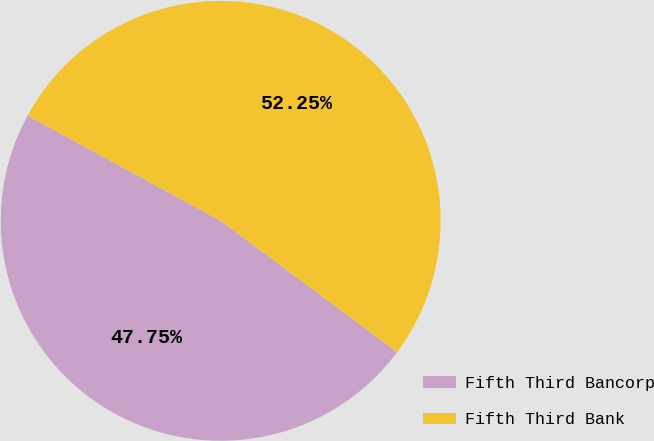<chart> <loc_0><loc_0><loc_500><loc_500><pie_chart><fcel>Fifth Third Bancorp<fcel>Fifth Third Bank<nl><fcel>47.75%<fcel>52.25%<nl></chart> 